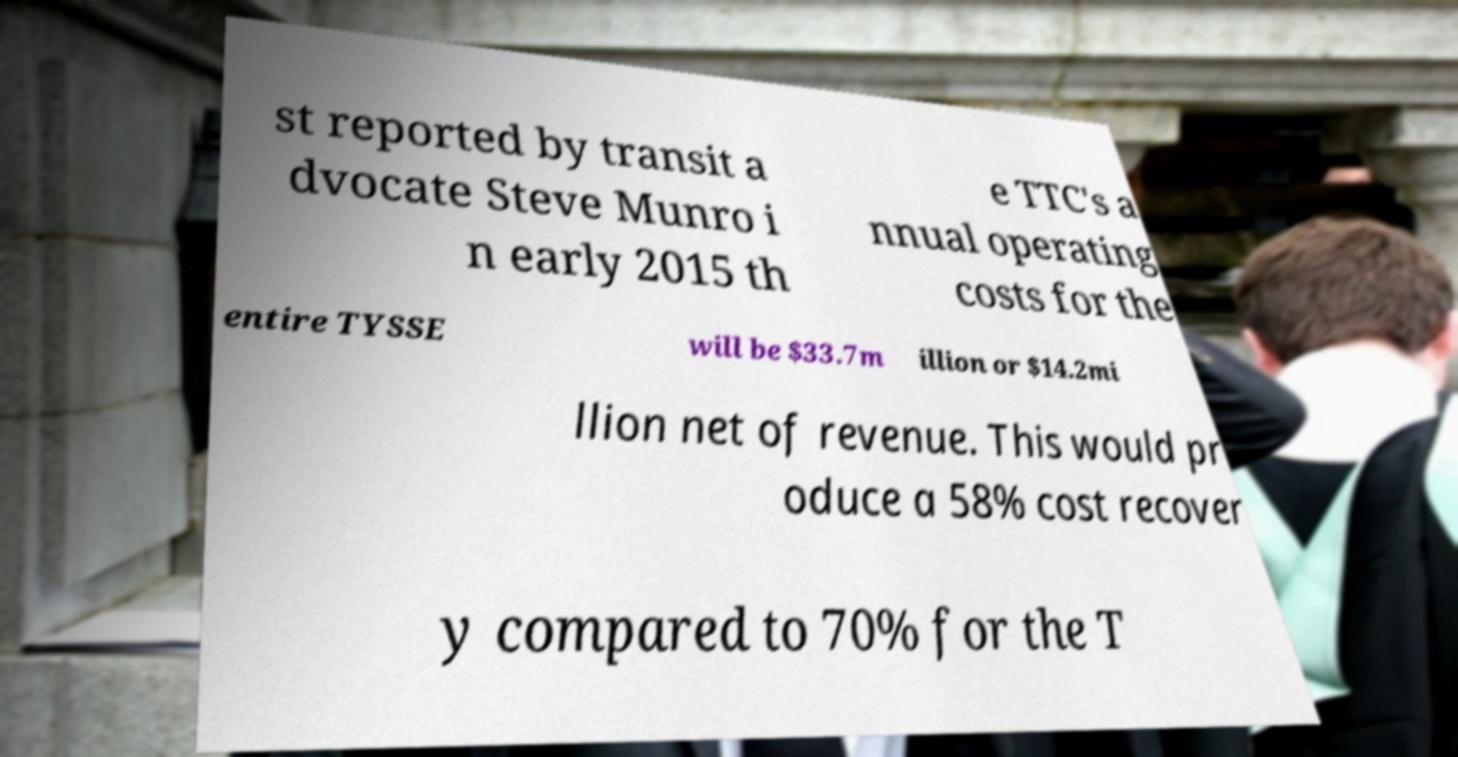Please read and relay the text visible in this image. What does it say? st reported by transit a dvocate Steve Munro i n early 2015 th e TTC's a nnual operating costs for the entire TYSSE will be $33.7m illion or $14.2mi llion net of revenue. This would pr oduce a 58% cost recover y compared to 70% for the T 